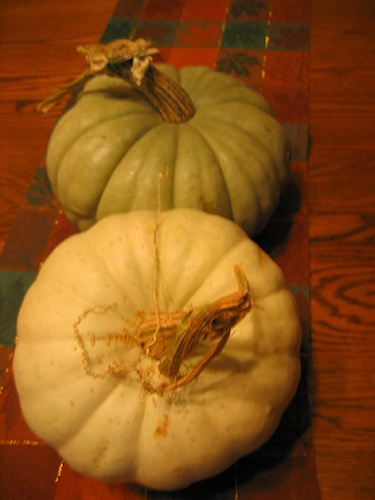<image>
Is the pumkin one under the pumpkin two? Yes. The pumkin one is positioned underneath the pumpkin two, with the pumpkin two above it in the vertical space. 